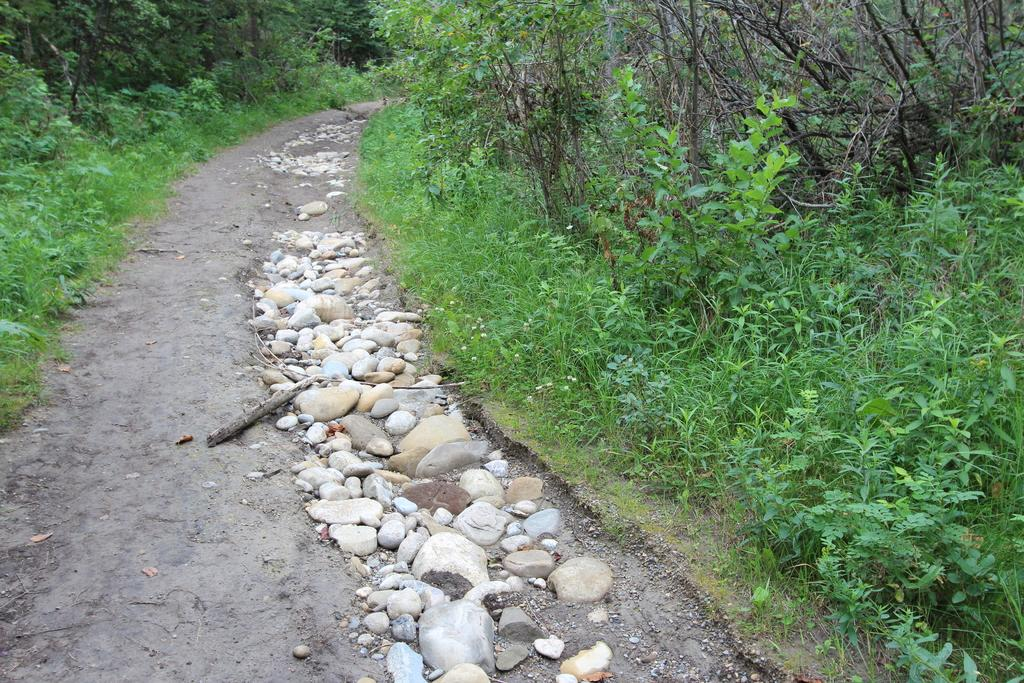What is the main subject of the image? The main subject of the image is a way. What type of vegetation can be seen in the image? There are green plants and trees in the image. Can you see a star shining brightly in the image? There is no star present in the image. Are there any people swimming in the image? There is no swimming or water visible in the image. 